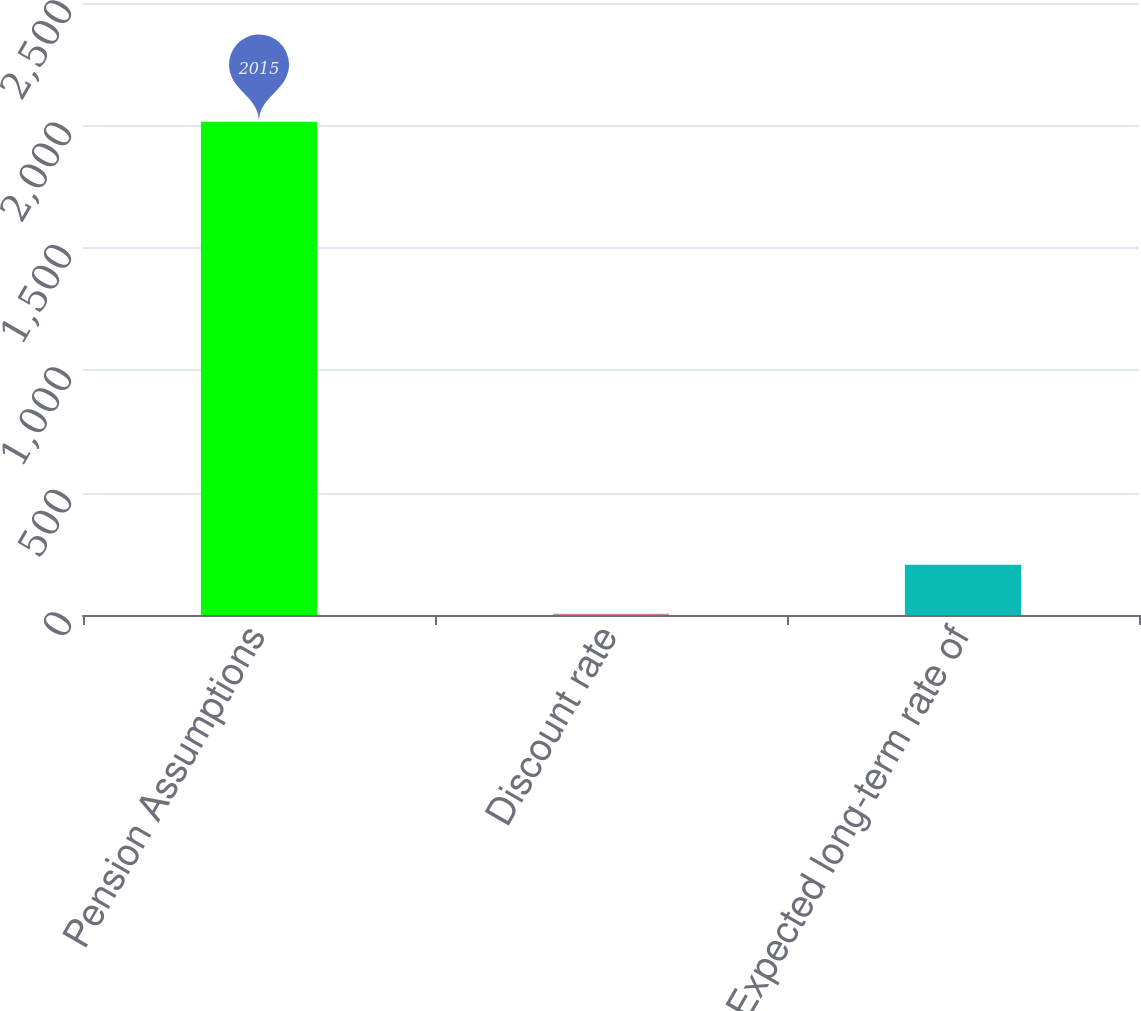<chart> <loc_0><loc_0><loc_500><loc_500><bar_chart><fcel>Pension Assumptions<fcel>Discount rate<fcel>Expected long-term rate of<nl><fcel>2015<fcel>4.66<fcel>205.69<nl></chart> 